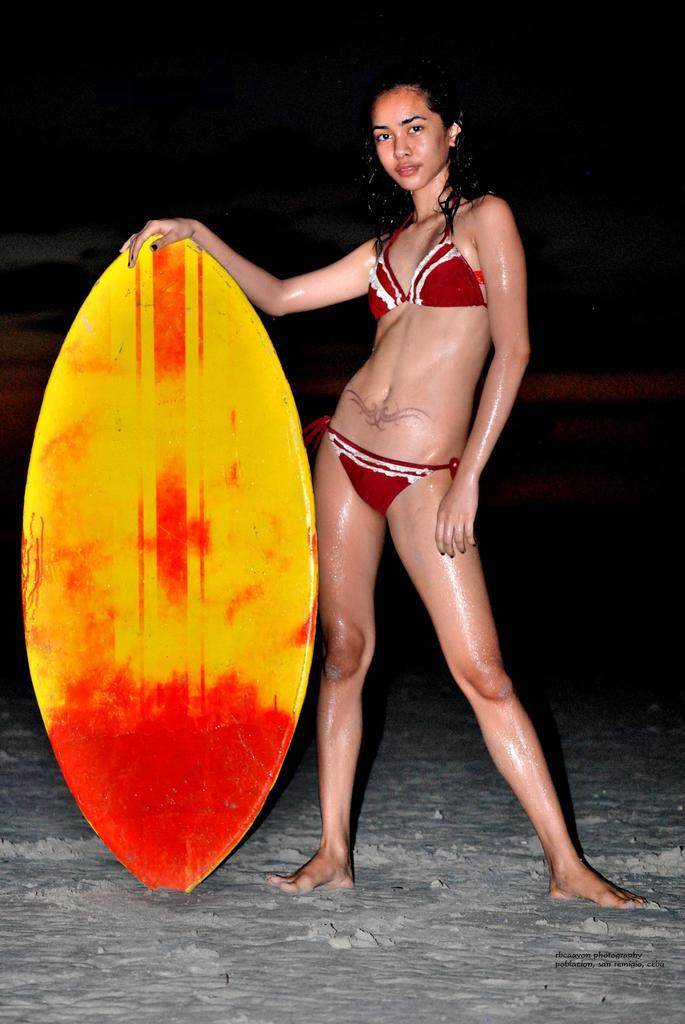Who is the main subject in the image? There is a woman in the image. What is the woman doing with her hands? The woman has her hands on a surfboard. What is the woman's action or expression in the image? The woman is posing for a camera. What can be observed about the lighting or color of the background in the image? The background of the image is dark. What theory does the woman's aunt mention in the image? There is no mention of an aunt or any theory in the image; it features a woman posing with a surfboard against a dark background. 